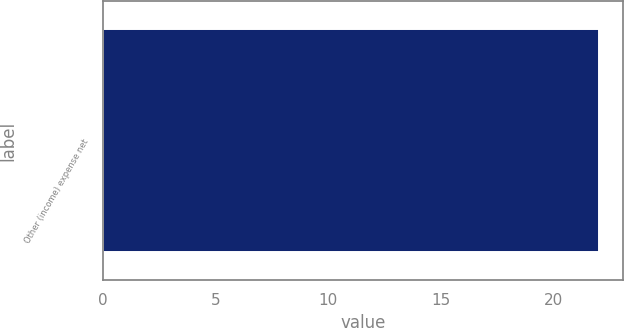Convert chart to OTSL. <chart><loc_0><loc_0><loc_500><loc_500><bar_chart><fcel>Other (income) expense net<nl><fcel>22<nl></chart> 